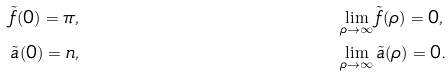<formula> <loc_0><loc_0><loc_500><loc_500>& \tilde { f } ( 0 ) = \pi , & & \lim _ { \rho \to \infty } \tilde { f } ( \rho ) = 0 , \\ & \tilde { a } ( 0 ) = n , & & \lim _ { \rho \to \infty } \tilde { a } ( \rho ) = 0 .</formula> 